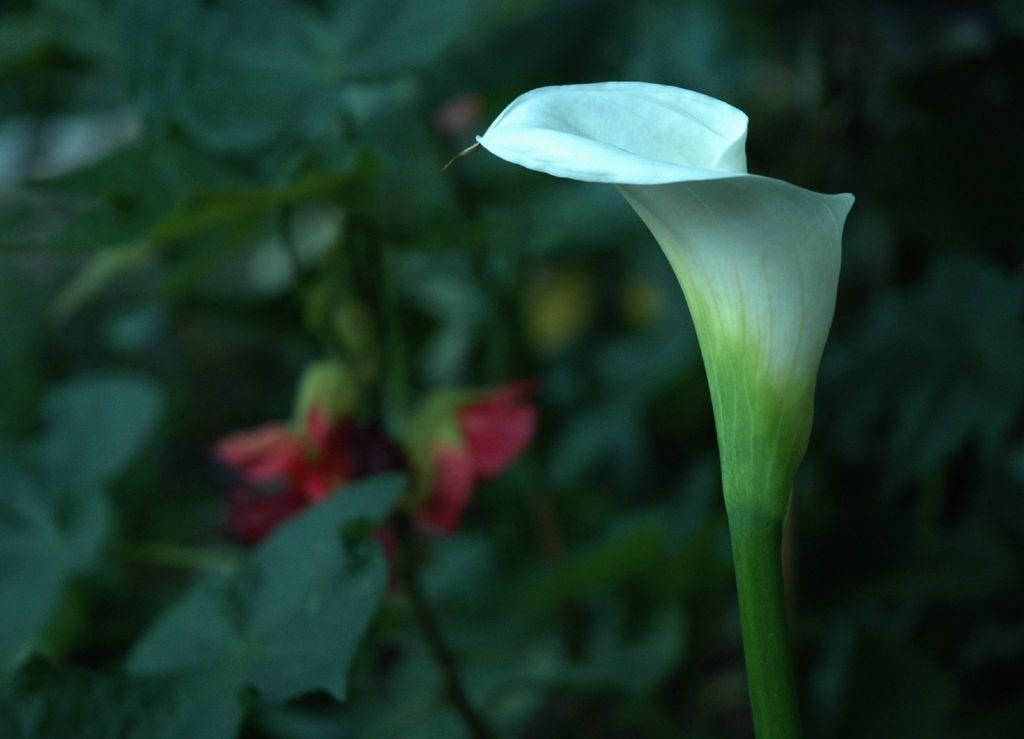What color is the flower in the image? The flower in the image is white. What else can be seen in the background of the image? There are plants and flowers in red color in the background of the image. How is the background of the image depicted? The background of the image is blurred. How does the flower control the trip to the limit in the image? The flower does not control any trip or limit in the image; it is a stationary object in the scene. 